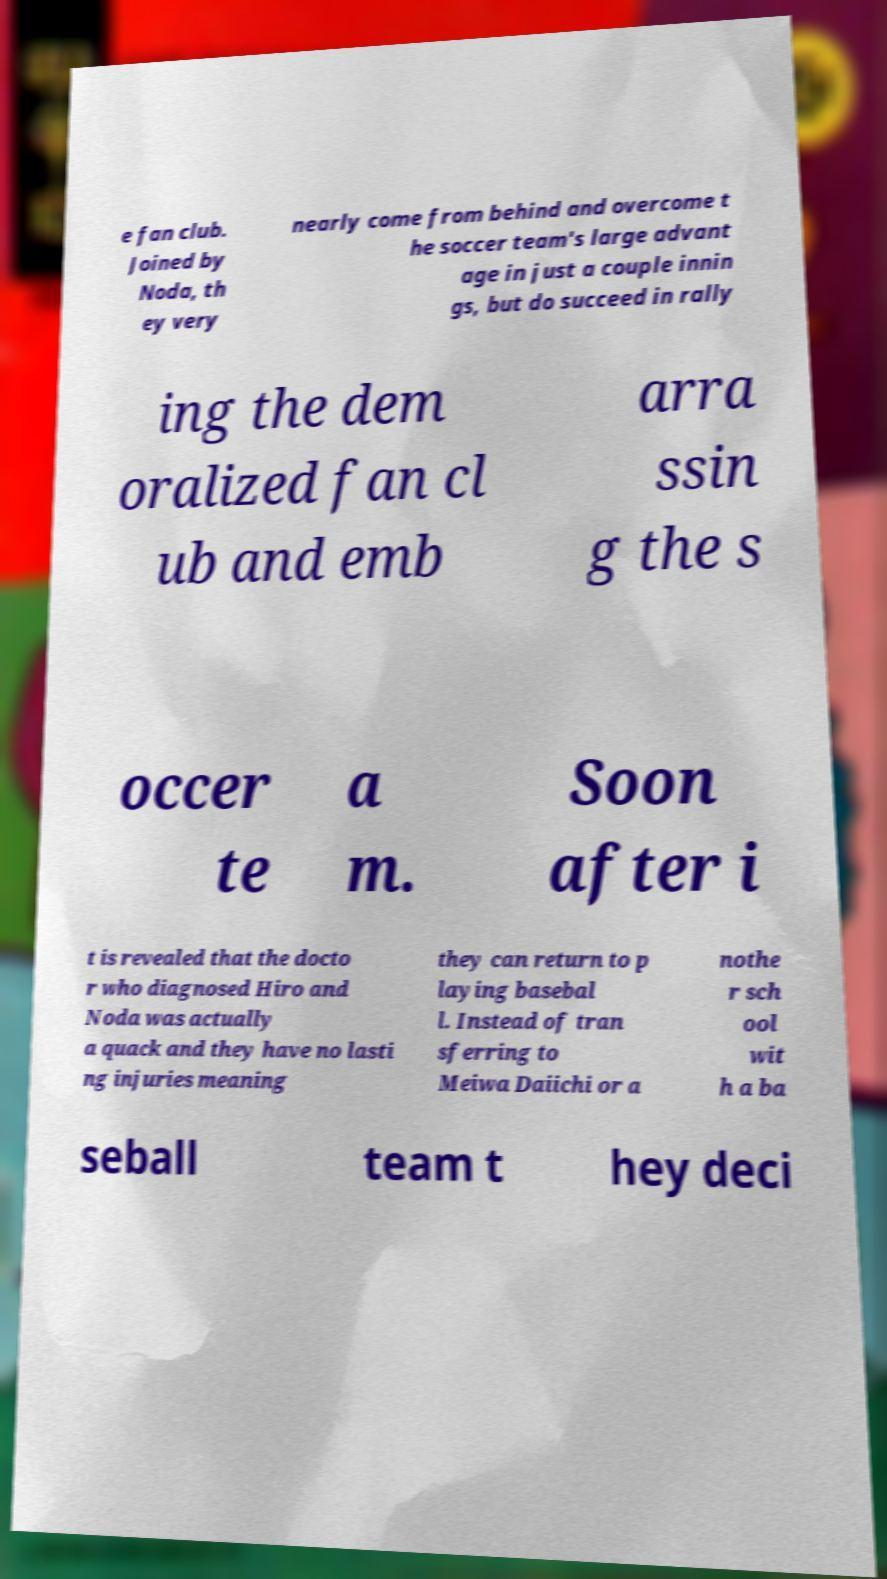Can you read and provide the text displayed in the image?This photo seems to have some interesting text. Can you extract and type it out for me? e fan club. Joined by Noda, th ey very nearly come from behind and overcome t he soccer team's large advant age in just a couple innin gs, but do succeed in rally ing the dem oralized fan cl ub and emb arra ssin g the s occer te a m. Soon after i t is revealed that the docto r who diagnosed Hiro and Noda was actually a quack and they have no lasti ng injuries meaning they can return to p laying basebal l. Instead of tran sferring to Meiwa Daiichi or a nothe r sch ool wit h a ba seball team t hey deci 